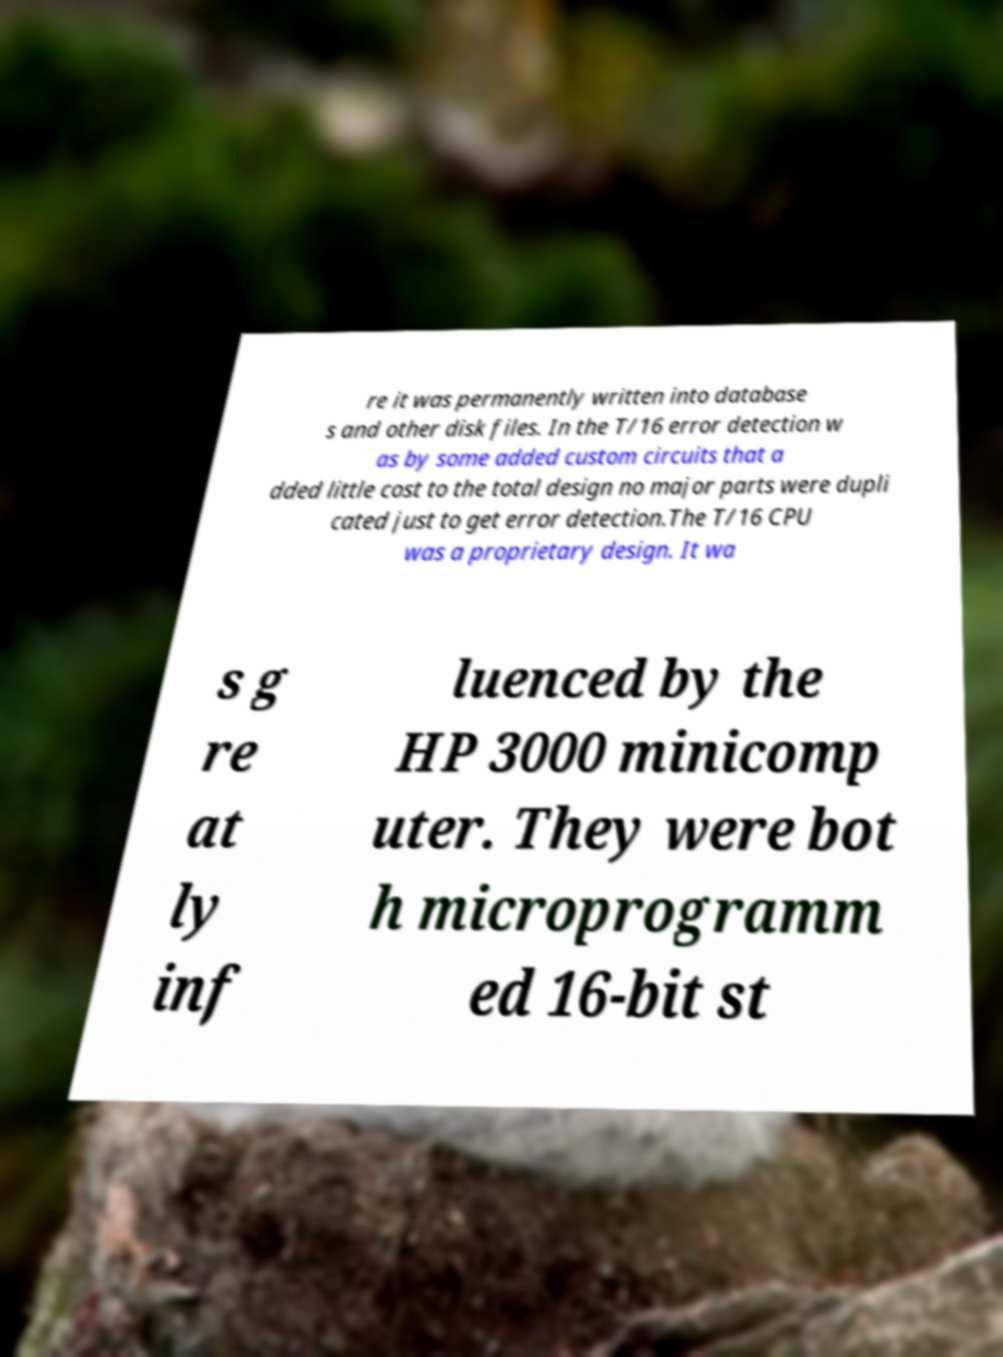For documentation purposes, I need the text within this image transcribed. Could you provide that? re it was permanently written into database s and other disk files. In the T/16 error detection w as by some added custom circuits that a dded little cost to the total design no major parts were dupli cated just to get error detection.The T/16 CPU was a proprietary design. It wa s g re at ly inf luenced by the HP 3000 minicomp uter. They were bot h microprogramm ed 16-bit st 